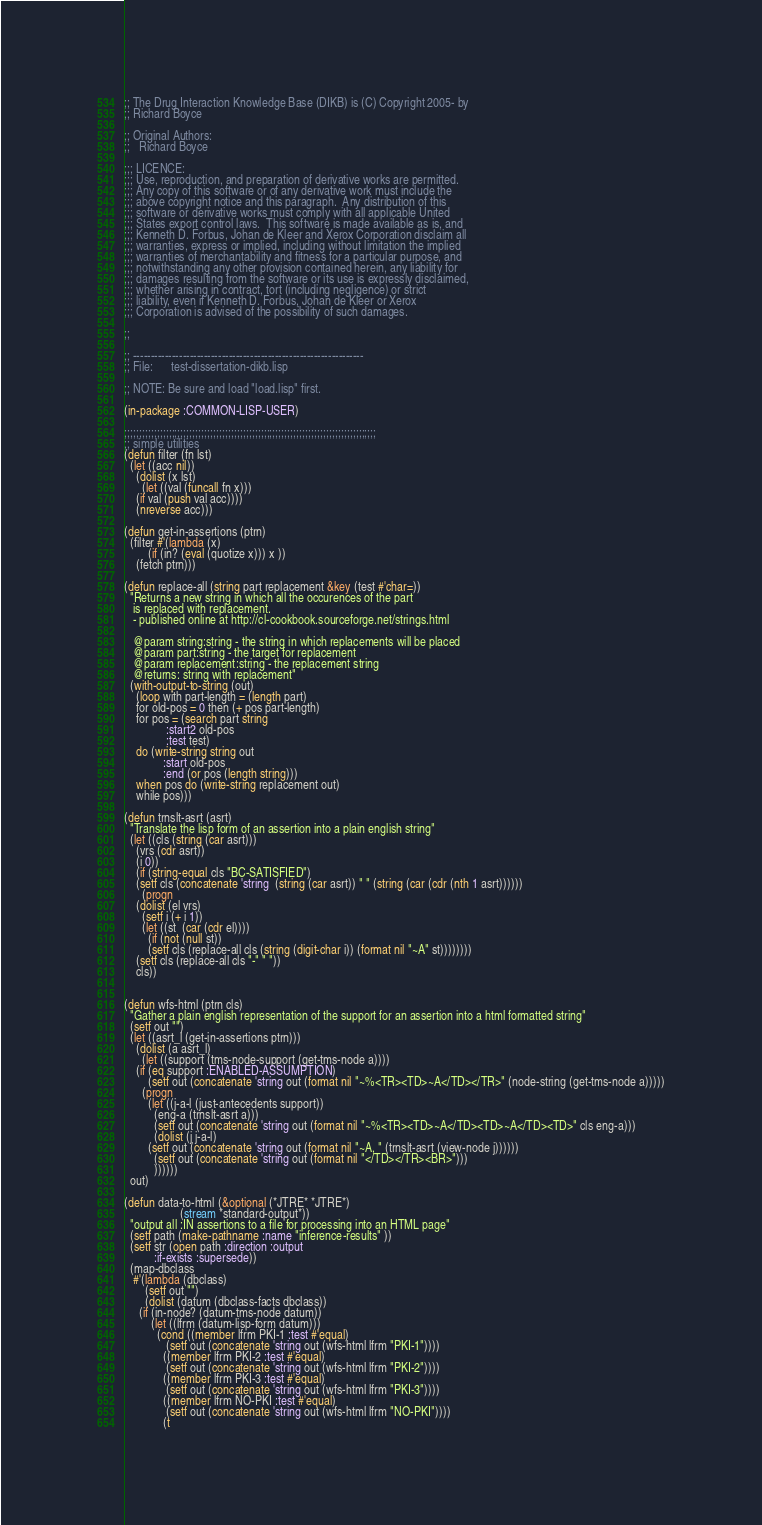<code> <loc_0><loc_0><loc_500><loc_500><_Lisp_>;; The Drug Interaction Knowledge Base (DIKB) is (C) Copyright 2005- by
;; Richard Boyce

;; Original Authors:
;;   Richard Boyce

;;; LICENCE:
;;; Use, reproduction, and preparation of derivative works are permitted.
;;; Any copy of this software or of any derivative work must include the
;;; above copyright notice and this paragraph.  Any distribution of this
;;; software or derivative works must comply with all applicable United
;;; States export control laws.  This software is made available as is, and
;;; Kenneth D. Forbus, Johan de Kleer and Xerox Corporation disclaim all
;;; warranties, express or implied, including without limitation the implied
;;; warranties of merchantability and fitness for a particular purpose, and
;;; notwithstanding any other provision contained herein, any liability for
;;; damages resulting from the software or its use is expressly disclaimed,
;;; whether arising in contract, tort (including negligence) or strict
;;; liability, even if Kenneth D. Forbus, Johan de Kleer or Xerox
;;; Corporation is advised of the possibility of such damages.

;;

;; -----------------------------------------------------------------
;; File:      test-dissertation-dikb.lisp

;; NOTE: Be sure and load "load.lisp" first.

(in-package :COMMON-LISP-USER)

;;;;;;;;;;;;;;;;;;;;;;;;;;;;;;;;;;;;;;;;;;;;;;;;;;;;;;;;;;;;;;;;;;;;;;;;;;;;;;;;;;;;;
;; simple utilities
(defun filter (fn lst)
  (let ((acc nil))
    (dolist (x lst)
      (let ((val (funcall fn x)))
	(if val (push val acc))))
    (nreverse acc)))

(defun get-in-assertions (ptrn)
  (filter #'(lambda (x)
	    (if (in? (eval (quotize x))) x ))
	(fetch ptrn)))

(defun replace-all (string part replacement &key (test #'char=))
  "Returns a new string in which all the occurences of the part 
   is replaced with replacement. 
   - published online at http://cl-cookbook.sourceforge.net/strings.html
   
   @param string:string - the string in which replacements will be placed
   @param part:string - the target for replacement
   @param replacement:string - the replacement string
   @returns: string with replacement"
  (with-output-to-string (out)
    (loop with part-length = (length part)
	for old-pos = 0 then (+ pos part-length)
	for pos = (search part string
			  :start2 old-pos
			  :test test)
	do (write-string string out
			 :start old-pos
			 :end (or pos (length string)))
	when pos do (write-string replacement out)
	while pos))) 
 
(defun trnslt-asrt (asrt)
  "Translate the lisp form of an assertion into a plain english string"
  (let ((cls (string (car asrt)))
	(vrs (cdr asrt))
	(i 0))
    (if (string-equal cls "BC-SATISFIED")
	(setf cls (concatenate 'string  (string (car asrt)) " " (string (car (cdr (nth 1 asrt))))))
      (progn
	(dolist (el vrs)
	  (setf i (+ i 1))
	  (let ((st  (car (cdr el))))
	    (if (not (null st))
		(setf cls (replace-all cls (string (digit-char i)) (format nil "~A" st))))))))
    (setf cls (replace-all cls "-" " "))
    cls))
	     

(defun wfs-html (ptrn cls)
  "Gather a plain english representation of the support for an assertion into a html formatted string"
  (setf out "")
  (let ((asrt_l (get-in-assertions ptrn)))
    (dolist (a asrt_l)
      (let ((support (tms-node-support (get-tms-node a))))
	(if (eq support :ENABLED-ASSUMPTION)
	    (setf out (concatenate 'string out (format nil "~%<TR><TD>~A</TD></TR>" (node-string (get-tms-node a)))))
	  (progn
	    (let ((j-a-l (just-antecedents support))
		  (eng-a (trnslt-asrt a)))
	      (setf out (concatenate 'string out (format nil "~%<TR><TD>~A</TD><TD>~A</TD><TD>" cls eng-a)))
	      (dolist (j j-a-l)
		(setf out (concatenate 'string out (format nil "~A, " (trnslt-asrt (view-node j))))))
	      (setf out (concatenate 'string out (format nil "</TD></TR><BR>")))
	      ))))))
  out)

(defun data-to-html (&optional (*JTRE* *JTRE*)
			       (stream *standard-output*))
  "output all :IN assertions to a file for processing into an HTML page"
  (setf path (make-pathname :name "inference-results" ))
  (setf str (open path :direction :output 
		  :if-exists :supersede))
  (map-dbclass
   #'(lambda (dbclass)
       (setf out "")
       (dolist (datum (dbclass-facts dbclass))
	 (if (in-node? (datum-tms-node datum))
	     (let ((lfrm (datum-lisp-form datum)))
	       (cond ((member lfrm PKI-1 :test #'equal)
		      (setf out (concatenate 'string out (wfs-html lfrm "PKI-1"))))
		     ((member lfrm PKI-2 :test #'equal)
		      (setf out (concatenate 'string out (wfs-html lfrm "PKI-2"))))
		     ((member lfrm PKI-3 :test #'equal)
		      (setf out (concatenate 'string out (wfs-html lfrm "PKI-3"))))
		     ((member lfrm NO-PKI :test #'equal)
		      (setf out (concatenate 'string out (wfs-html lfrm "NO-PKI"))))
		     (t</code> 